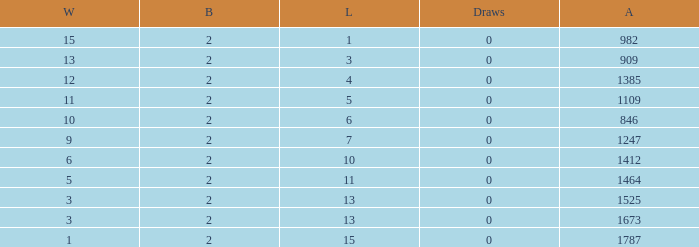What is the average number of Byes when there were less than 0 losses and were against 1247? None. 